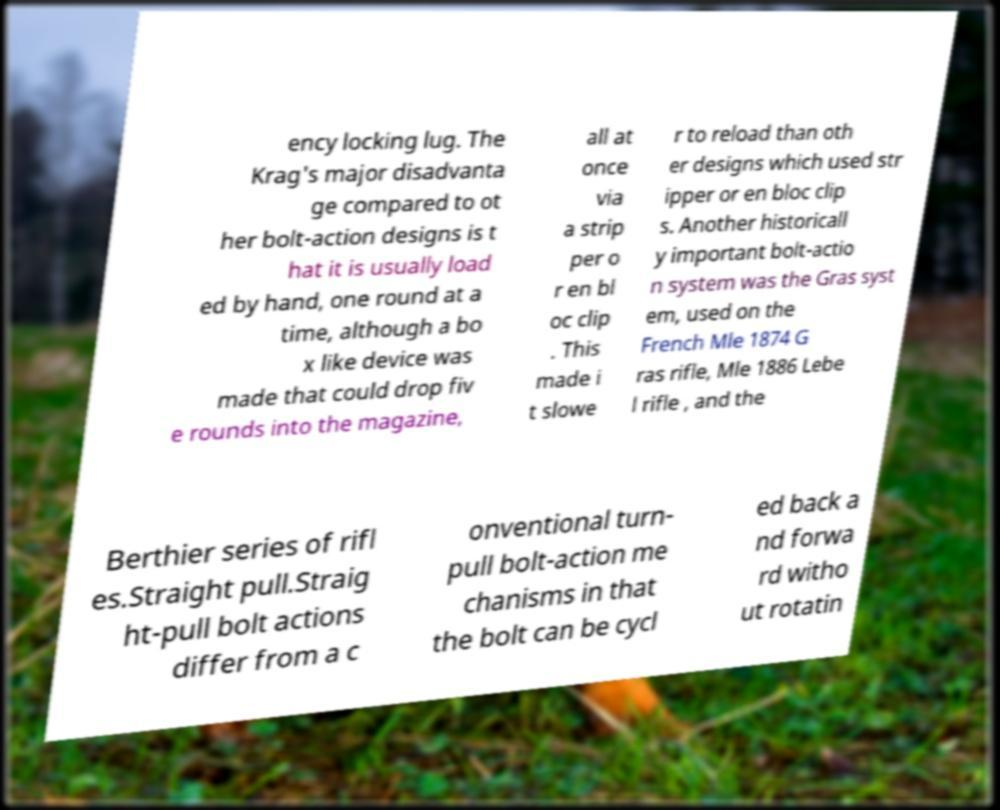What messages or text are displayed in this image? I need them in a readable, typed format. ency locking lug. The Krag's major disadvanta ge compared to ot her bolt-action designs is t hat it is usually load ed by hand, one round at a time, although a bo x like device was made that could drop fiv e rounds into the magazine, all at once via a strip per o r en bl oc clip . This made i t slowe r to reload than oth er designs which used str ipper or en bloc clip s. Another historicall y important bolt-actio n system was the Gras syst em, used on the French Mle 1874 G ras rifle, Mle 1886 Lebe l rifle , and the Berthier series of rifl es.Straight pull.Straig ht-pull bolt actions differ from a c onventional turn- pull bolt-action me chanisms in that the bolt can be cycl ed back a nd forwa rd witho ut rotatin 